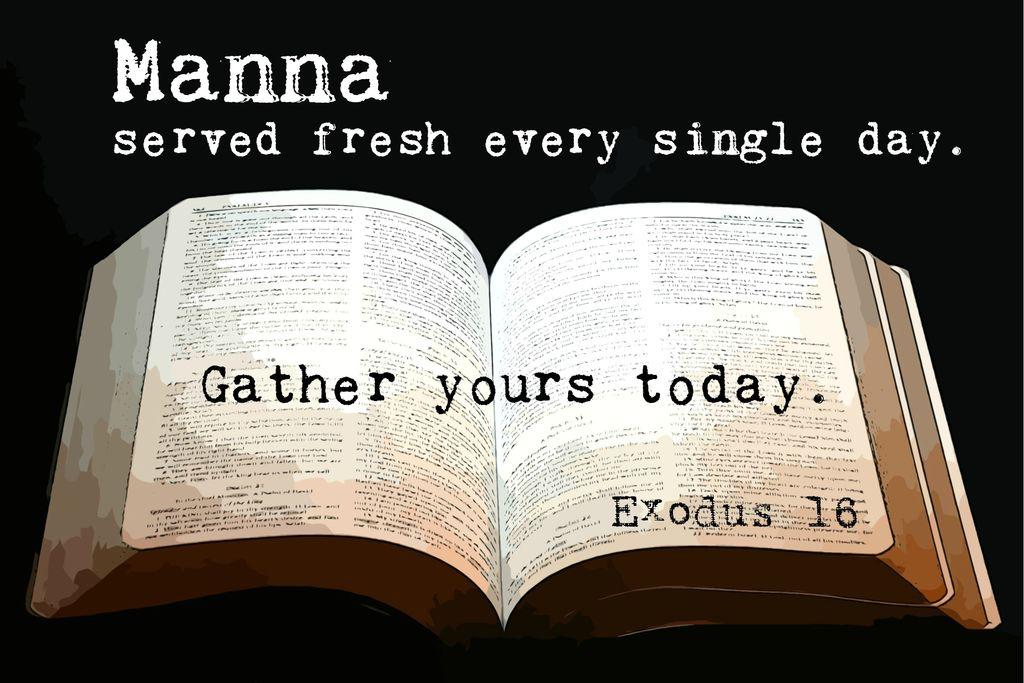<image>
Summarize the visual content of the image. a book that says gather yours today in it 